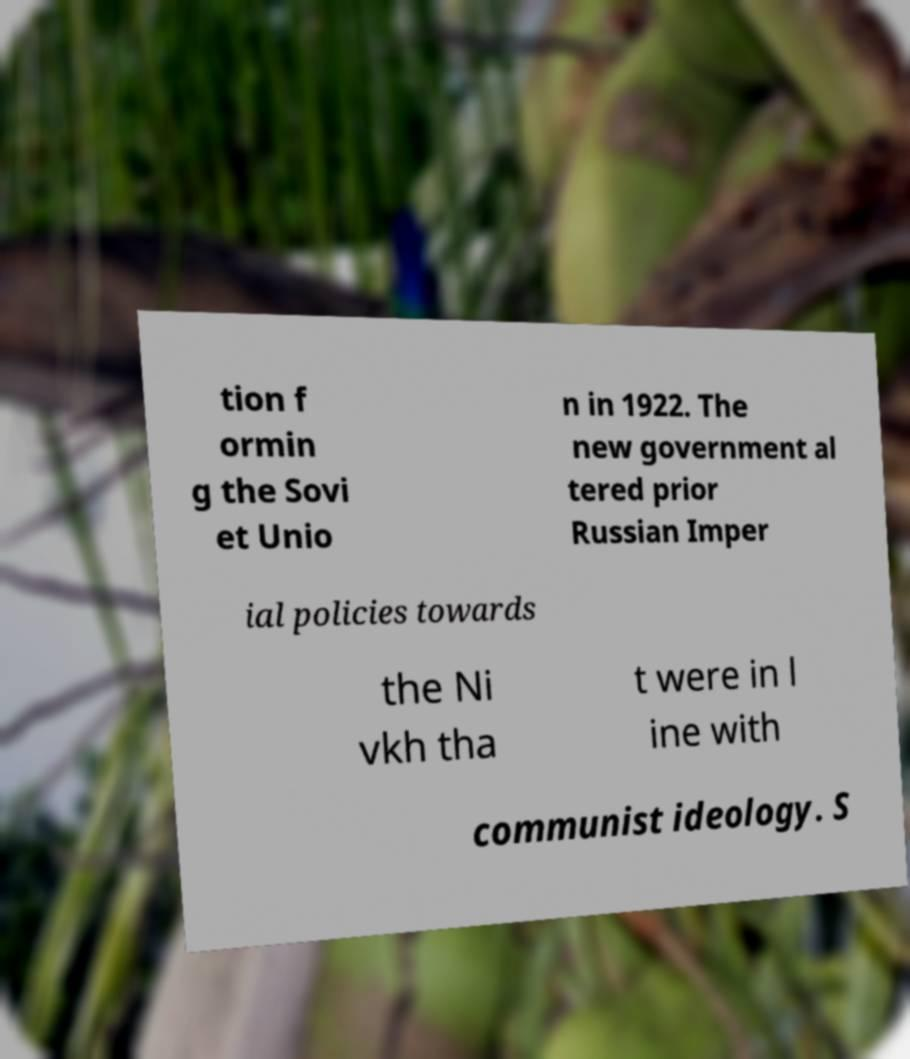Please read and relay the text visible in this image. What does it say? tion f ormin g the Sovi et Unio n in 1922. The new government al tered prior Russian Imper ial policies towards the Ni vkh tha t were in l ine with communist ideology. S 